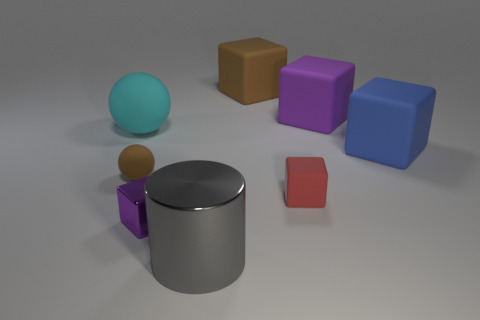What shape is the blue rubber thing that is the same size as the gray shiny cylinder?
Keep it short and to the point. Cube. What number of other objects are there of the same color as the metallic block?
Ensure brevity in your answer.  1. What is the color of the large rubber object right of the big purple cube?
Give a very brief answer. Blue. How many other objects are the same material as the tiny red thing?
Your answer should be very brief. 5. Are there more cylinders that are left of the big gray shiny cylinder than big cyan matte objects that are right of the blue cube?
Provide a short and direct response. No. What number of blue blocks are behind the big cyan ball?
Your answer should be very brief. 0. Is the material of the brown ball the same as the brown thing that is behind the brown sphere?
Ensure brevity in your answer.  Yes. Is there anything else that is the same shape as the large purple thing?
Your answer should be very brief. Yes. Do the cylinder and the tiny red block have the same material?
Offer a very short reply. No. There is a purple object that is on the left side of the big gray thing; is there a blue matte block to the left of it?
Ensure brevity in your answer.  No. 